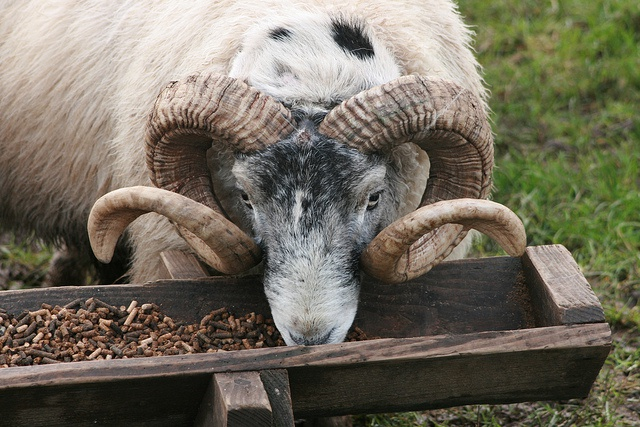Describe the objects in this image and their specific colors. I can see a sheep in lightgray, darkgray, gray, and black tones in this image. 